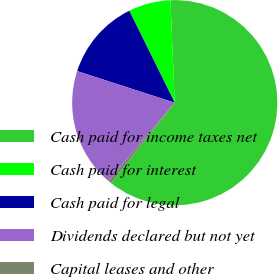<chart> <loc_0><loc_0><loc_500><loc_500><pie_chart><fcel>Cash paid for income taxes net<fcel>Cash paid for interest<fcel>Cash paid for legal<fcel>Dividends declared but not yet<fcel>Capital leases and other<nl><fcel>61.31%<fcel>6.63%<fcel>12.71%<fcel>18.78%<fcel>0.56%<nl></chart> 